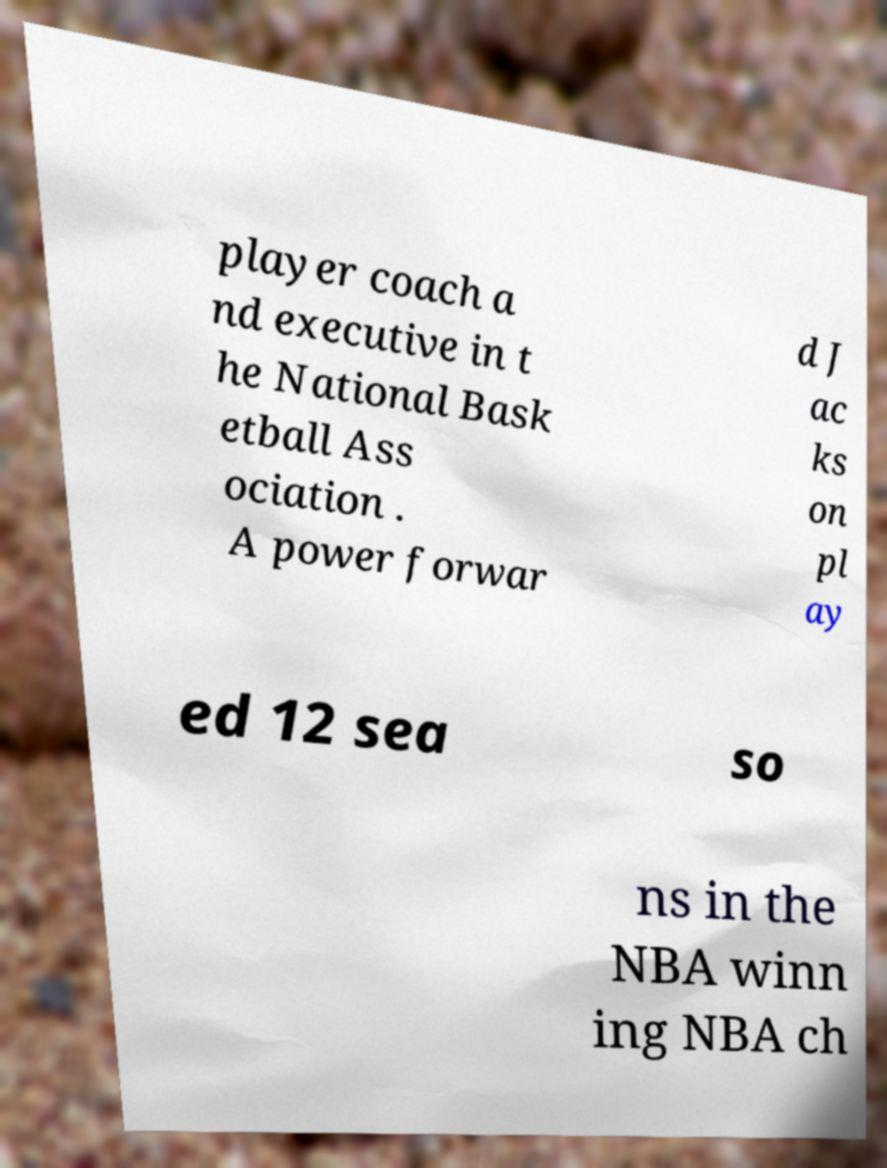Could you assist in decoding the text presented in this image and type it out clearly? player coach a nd executive in t he National Bask etball Ass ociation . A power forwar d J ac ks on pl ay ed 12 sea so ns in the NBA winn ing NBA ch 